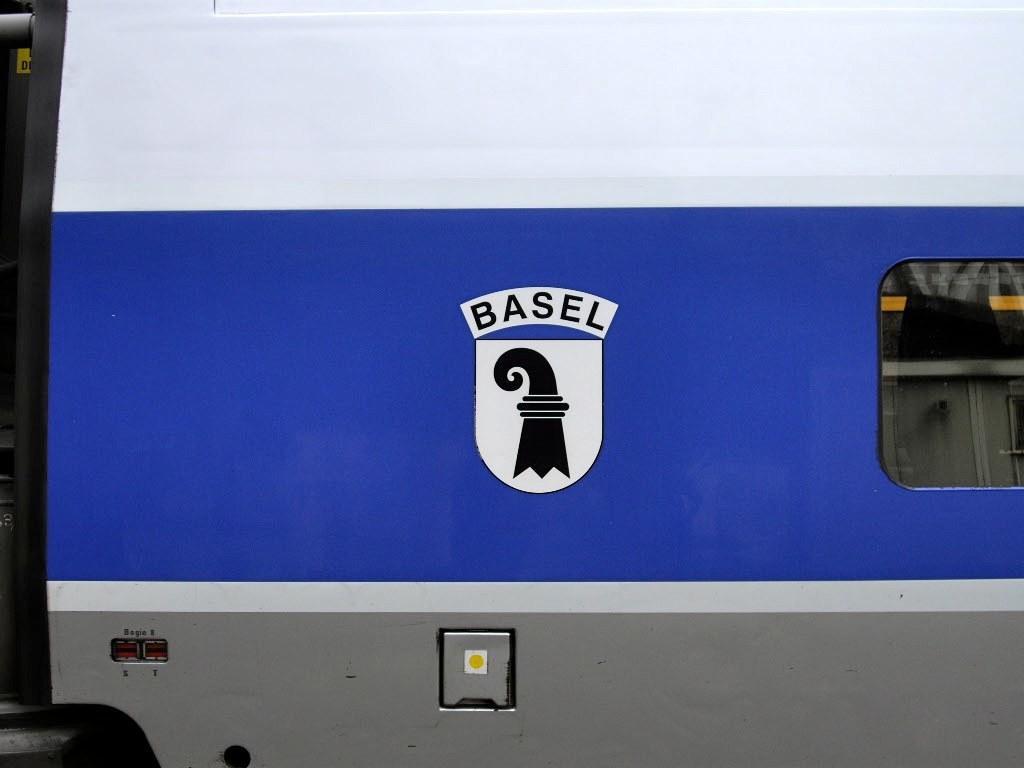In one or two sentences, can you explain what this image depicts? This is a picture of a logo on the vehicle. 